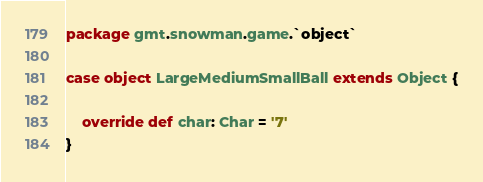Convert code to text. <code><loc_0><loc_0><loc_500><loc_500><_Scala_>package gmt.snowman.game.`object`

case object LargeMediumSmallBall extends Object {

    override def char: Char = '7'
}
</code> 